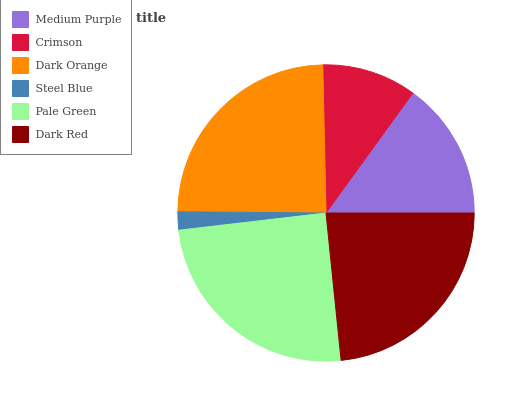Is Steel Blue the minimum?
Answer yes or no. Yes. Is Pale Green the maximum?
Answer yes or no. Yes. Is Crimson the minimum?
Answer yes or no. No. Is Crimson the maximum?
Answer yes or no. No. Is Medium Purple greater than Crimson?
Answer yes or no. Yes. Is Crimson less than Medium Purple?
Answer yes or no. Yes. Is Crimson greater than Medium Purple?
Answer yes or no. No. Is Medium Purple less than Crimson?
Answer yes or no. No. Is Dark Red the high median?
Answer yes or no. Yes. Is Medium Purple the low median?
Answer yes or no. Yes. Is Dark Orange the high median?
Answer yes or no. No. Is Dark Orange the low median?
Answer yes or no. No. 